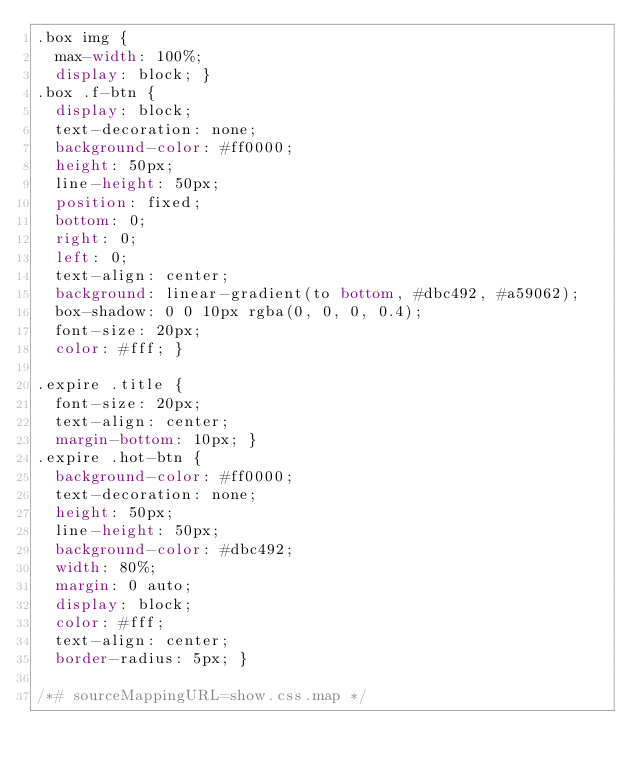Convert code to text. <code><loc_0><loc_0><loc_500><loc_500><_CSS_>.box img {
  max-width: 100%;
  display: block; }
.box .f-btn {
  display: block;
  text-decoration: none;
  background-color: #ff0000;
  height: 50px;
  line-height: 50px;
  position: fixed;
  bottom: 0;
  right: 0;
  left: 0;
  text-align: center;
  background: linear-gradient(to bottom, #dbc492, #a59062);
  box-shadow: 0 0 10px rgba(0, 0, 0, 0.4);
  font-size: 20px;
  color: #fff; }

.expire .title {
  font-size: 20px;
  text-align: center;
  margin-bottom: 10px; }
.expire .hot-btn {
  background-color: #ff0000;
  text-decoration: none;
  height: 50px;
  line-height: 50px;
  background-color: #dbc492;
  width: 80%;
  margin: 0 auto;
  display: block;
  color: #fff;
  text-align: center;
  border-radius: 5px; }

/*# sourceMappingURL=show.css.map */
</code> 